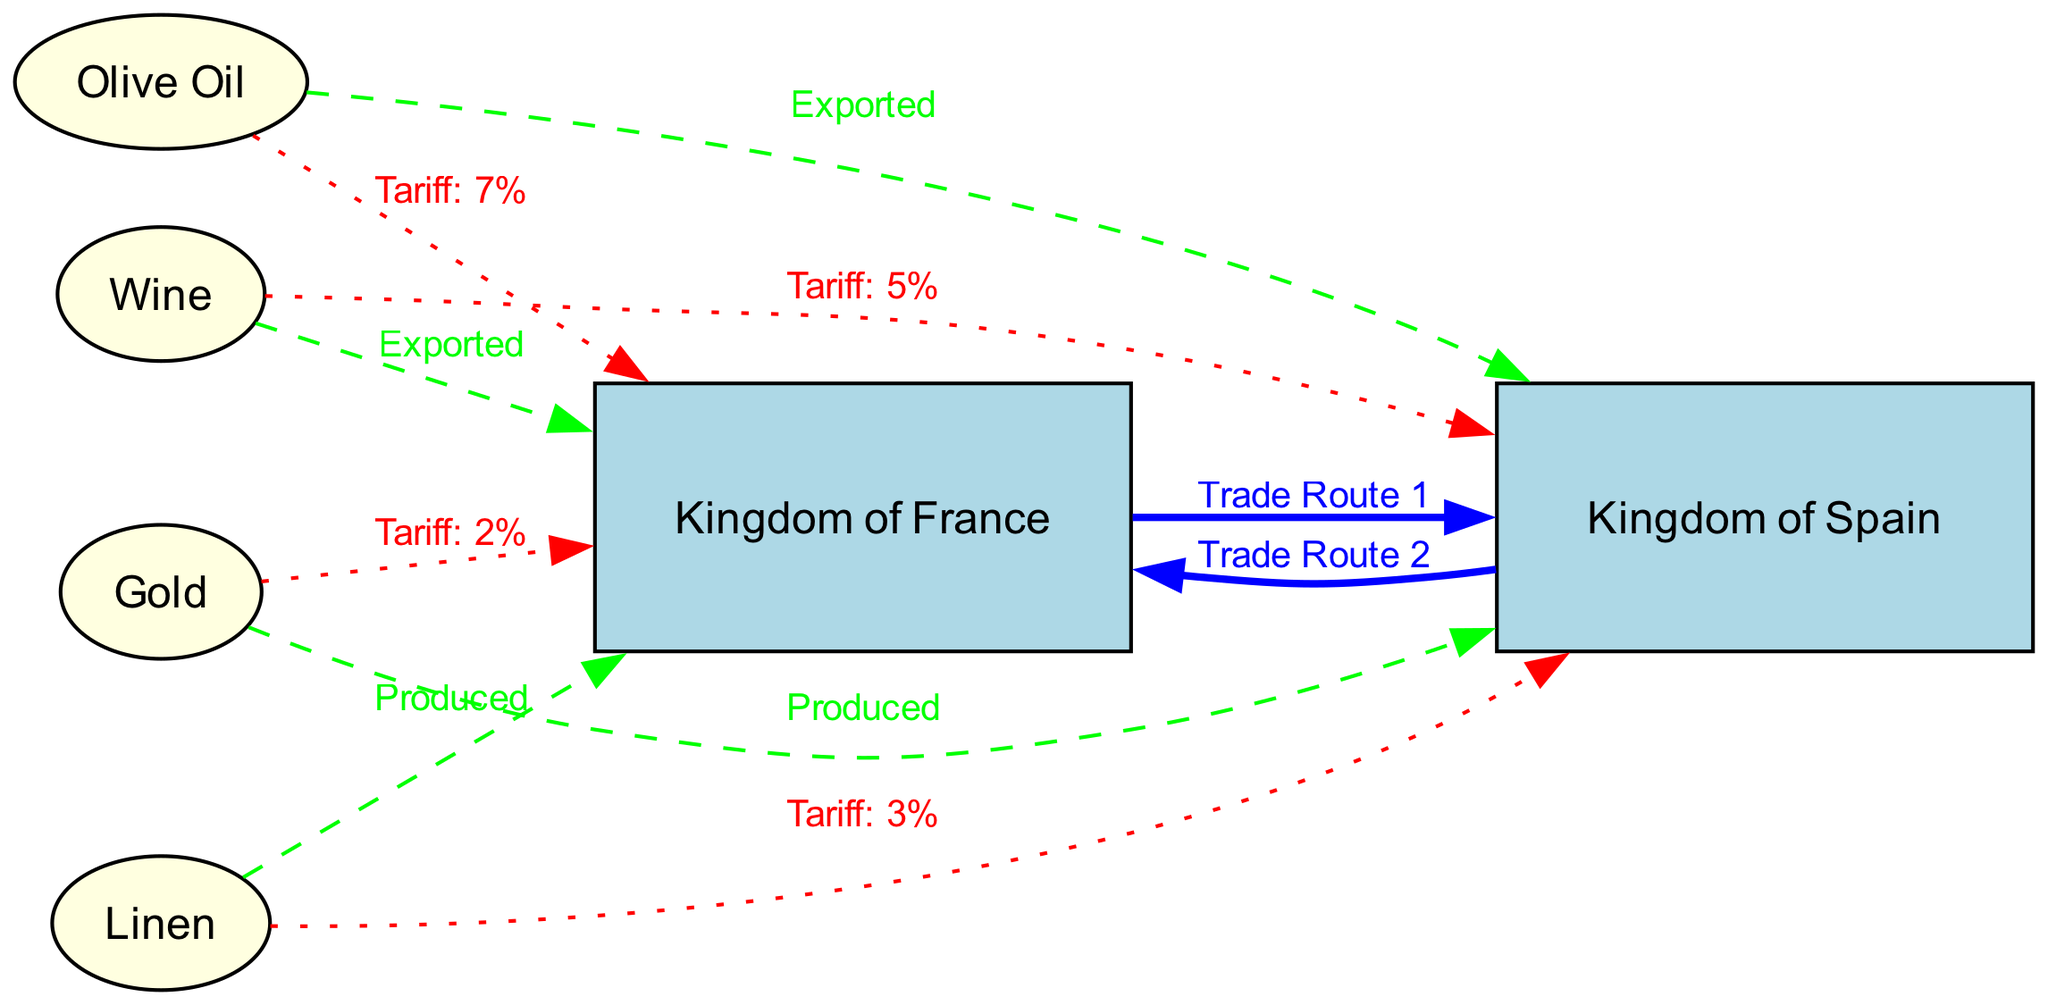What are the key commodities exported from the Kingdom of France? The diagram indicates that the commodities exported from the Kingdom of France are Wine and Linen.
Answer: Wine, Linen What is the tariff rate on Olive Oil exported to the Kingdom of France? The diagram shows that the tariff on Olive Oil, when exported to the Kingdom of France, is 7%.
Answer: 7% How many trade routes are shown between Kingdoms? The diagram illustrates two trade routes: Trade Route 1 from the Kingdom of France to the Kingdom of Spain and Trade Route 2 in the opposite direction.
Answer: 2 What is the tariff on Linen imported into the Kingdom of Spain? The diagram specifies that the tariff on Linen, when imported into the Kingdom of Spain, is 3%.
Answer: 3% Which kingdom produces Gold? The diagram clearly indicates that the Kingdom of Spain is the producer of Gold.
Answer: Kingdom of Spain What is the relationship between the commodity Wine and the Kingdom of Spain? The diagram shows that Wine, exported from the Kingdom of France, is subject to a tariff of 5% when it reaches the Kingdom of Spain.
Answer: Tariff: 5% Which commodity has the highest tariff when traded? The diagram shows that the tariff on Olive Oil, imported into the Kingdom of France, is 7%, which is higher than the tariffs on other commodities.
Answer: 7% What is the most frequently mentioned type of edge in the diagram? The diagram predominantly features 'tariff' edges, indicating the impositions on trade between the commodities and the kingdoms.
Answer: Tariff Which commodity does the Kingdom of France export? According to the diagram, the Kingdom of France exports Wine.
Answer: Wine 